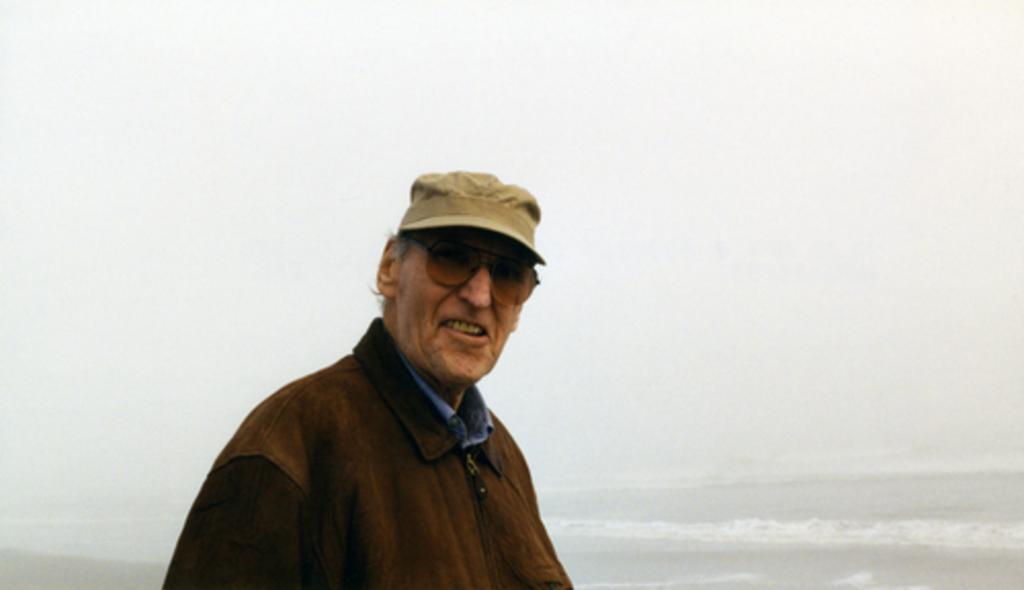Could you give a brief overview of what you see in this image? In this picture we can see an old man wearing a cap standing in front of the sea and smiling at someone. 